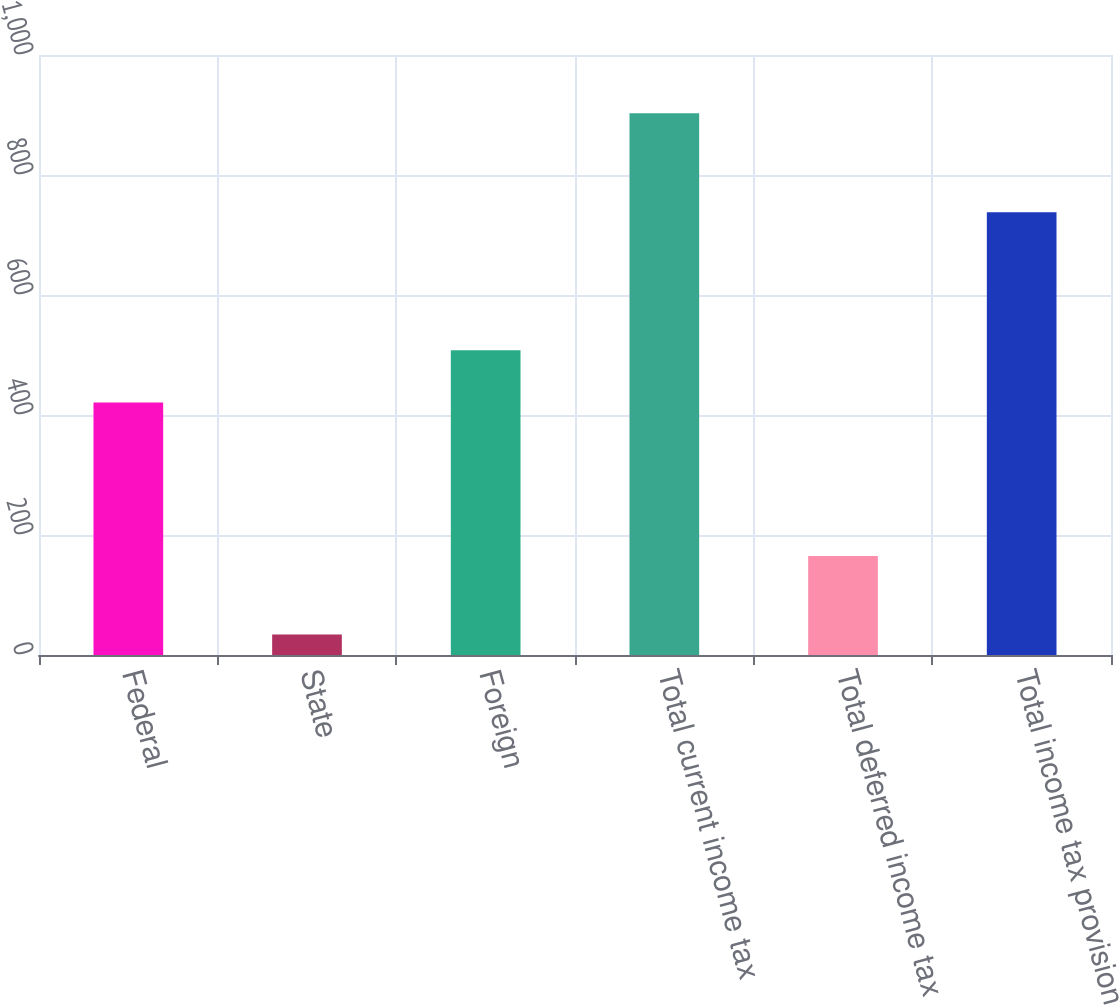<chart> <loc_0><loc_0><loc_500><loc_500><bar_chart><fcel>Federal<fcel>State<fcel>Foreign<fcel>Total current income tax<fcel>Total deferred income tax<fcel>Total income tax provision<nl><fcel>421<fcel>34<fcel>507.9<fcel>903<fcel>165<fcel>738<nl></chart> 